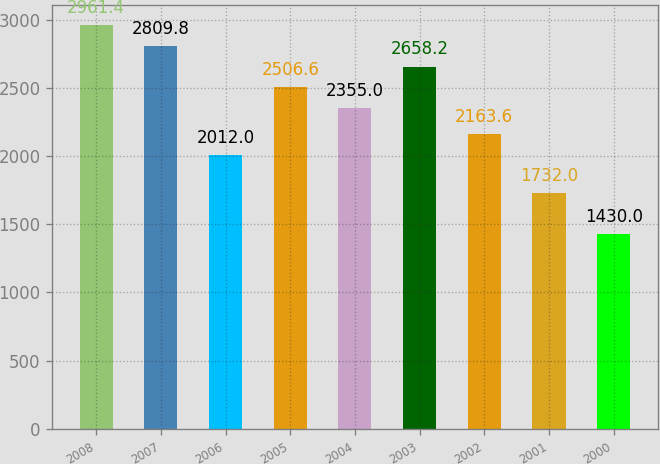Convert chart. <chart><loc_0><loc_0><loc_500><loc_500><bar_chart><fcel>2008<fcel>2007<fcel>2006<fcel>2005<fcel>2004<fcel>2003<fcel>2002<fcel>2001<fcel>2000<nl><fcel>2961.4<fcel>2809.8<fcel>2012<fcel>2506.6<fcel>2355<fcel>2658.2<fcel>2163.6<fcel>1732<fcel>1430<nl></chart> 